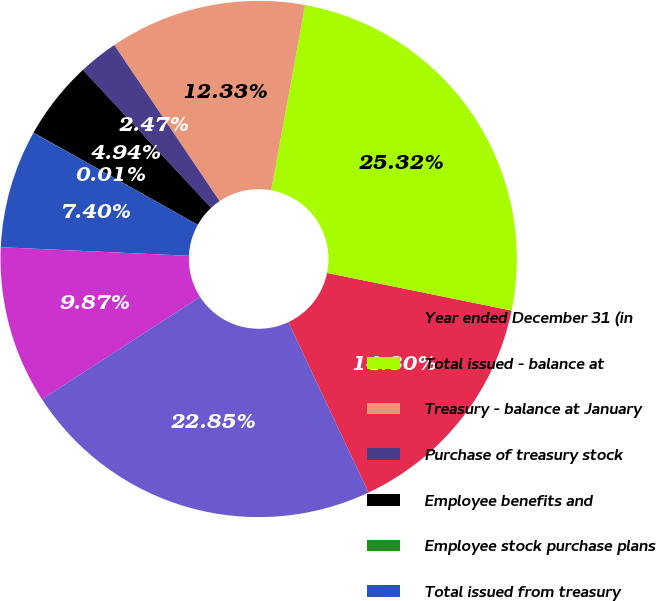Convert chart. <chart><loc_0><loc_0><loc_500><loc_500><pie_chart><fcel>Year ended December 31 (in<fcel>Total issued - balance at<fcel>Treasury - balance at January<fcel>Purchase of treasury stock<fcel>Employee benefits and<fcel>Employee stock purchase plans<fcel>Total issued from treasury<fcel>Total treasury - balance at<fcel>Outstanding<nl><fcel>14.8%<fcel>25.32%<fcel>12.33%<fcel>2.47%<fcel>4.94%<fcel>0.01%<fcel>7.4%<fcel>9.87%<fcel>22.85%<nl></chart> 